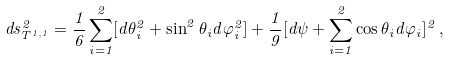<formula> <loc_0><loc_0><loc_500><loc_500>d s ^ { 2 } _ { T ^ { 1 , 1 } } = \frac { 1 } { 6 } \sum _ { i = 1 } ^ { 2 } [ d \theta _ { i } ^ { 2 } + \sin ^ { 2 } \theta _ { i } d \varphi _ { i } ^ { 2 } ] + \frac { 1 } { 9 } [ d \psi + \sum _ { i = 1 } ^ { 2 } \cos \theta _ { i } d \varphi _ { i } ] ^ { 2 } \, ,</formula> 